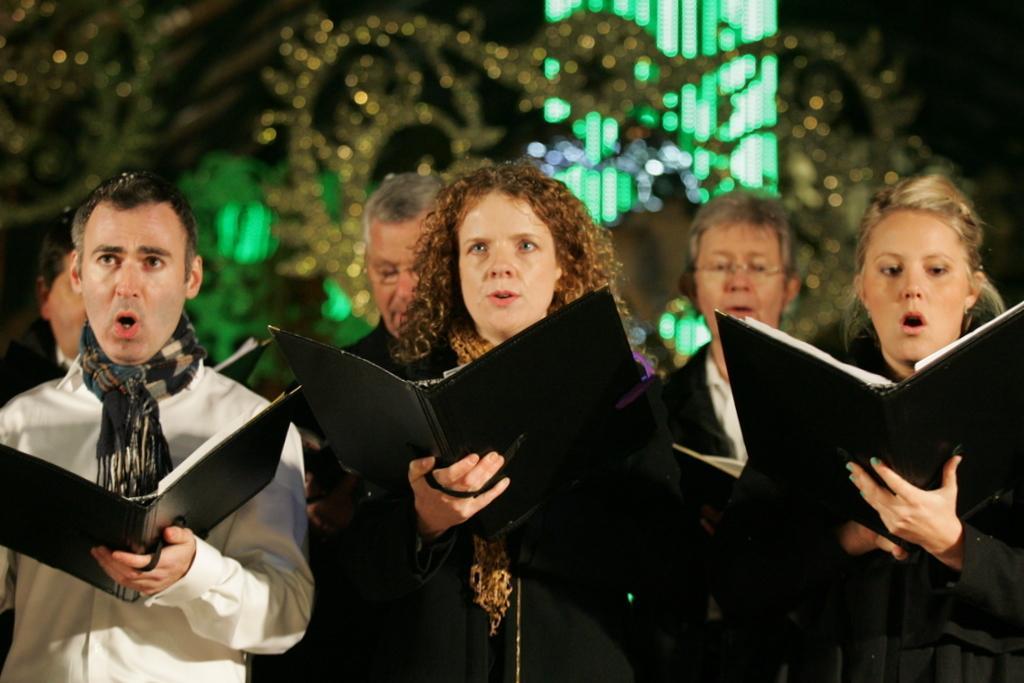Could you give a brief overview of what you see in this image? In the foreground I can see group of people are holding books in their hand. In the background I can see lights and the sky. This image is taken during night. 